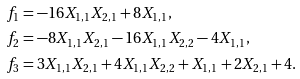<formula> <loc_0><loc_0><loc_500><loc_500>f _ { 1 } & = - 1 6 X _ { 1 , 1 } X _ { 2 , 1 } + 8 X _ { 1 , 1 } , \\ f _ { 2 } & = - 8 X _ { 1 , 1 } X _ { 2 , 1 } - 1 6 X _ { 1 , 1 } X _ { 2 , 2 } - 4 X _ { 1 , 1 } , \\ f _ { 3 } & = 3 X _ { 1 , 1 } X _ { 2 , 1 } + 4 X _ { 1 , 1 } X _ { 2 , 2 } + X _ { 1 , 1 } + 2 X _ { 2 , 1 } + 4 .</formula> 